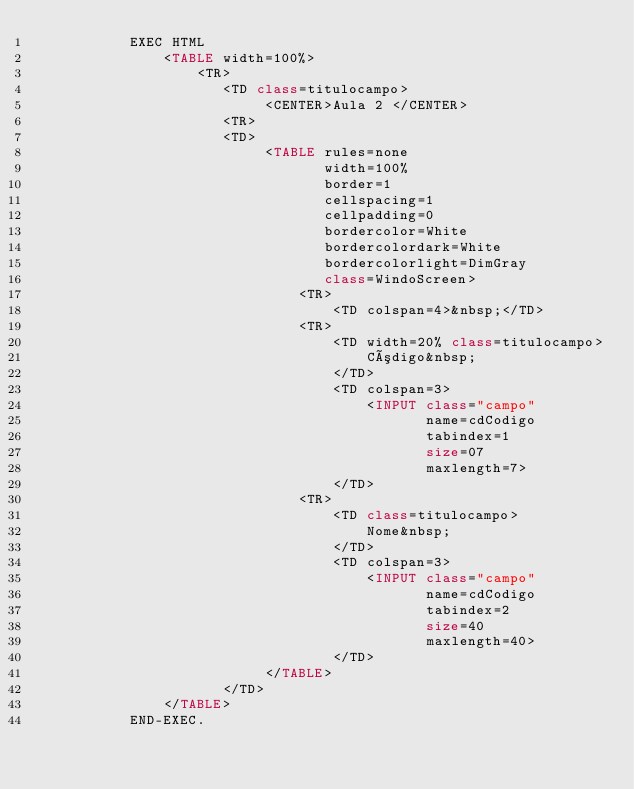Convert code to text. <code><loc_0><loc_0><loc_500><loc_500><_COBOL_>           EXEC HTML
               <TABLE width=100%>
                   <TR>
                      <TD class=titulocampo>
                           <CENTER>Aula 2 </CENTER>
                      <TR>
                      <TD>
                           <TABLE rules=none 
                                  width=100% 
                                  border=1
                                  cellspacing=1 
                                  cellpadding=0
                                  bordercolor=White 
                                  bordercolordark=White 
                                  bordercolorlight=DimGray 
                                  class=WindoScreen>
                               <TR>
                                   <TD colspan=4>&nbsp;</TD>
                               <TR>
                                   <TD width=20% class=titulocampo>
                                       Código&nbsp;
                                   </TD>
                                   <TD colspan=3>
                                       <INPUT class="campo" 
                                              name=cdCodigo 
                                              tabindex=1 
                                              size=07 
                                              maxlength=7>
                                   </TD>
                               <TR>
                                   <TD class=titulocampo>
                                       Nome&nbsp;
                                   </TD>
                                   <TD colspan=3>
                                       <INPUT class="campo" 
                                              name=cdCodigo 
                                              tabindex=2 
                                              size=40 
                                              maxlength=40>
                                   </TD>
                           </TABLE>
                      </TD>
               </TABLE>
           END-EXEC.</code> 